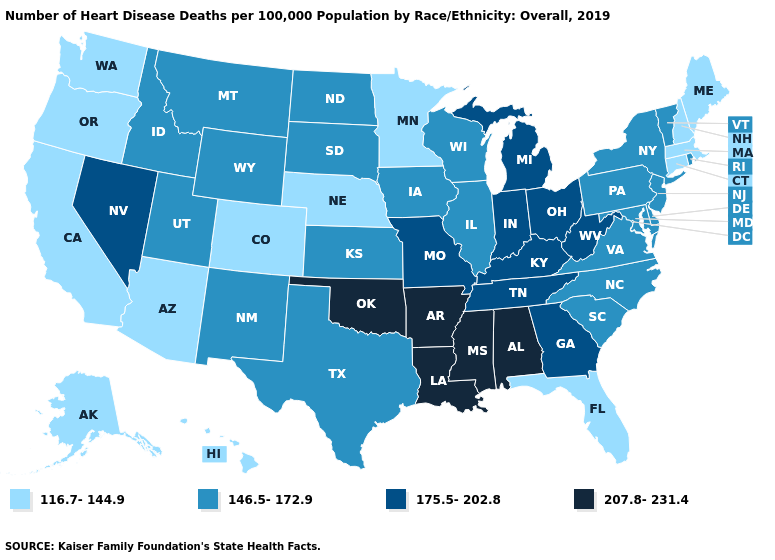What is the value of Maryland?
Short answer required. 146.5-172.9. Among the states that border Kansas , which have the lowest value?
Concise answer only. Colorado, Nebraska. Among the states that border Nebraska , does Kansas have the lowest value?
Keep it brief. No. What is the lowest value in the MidWest?
Concise answer only. 116.7-144.9. What is the value of Connecticut?
Give a very brief answer. 116.7-144.9. What is the value of West Virginia?
Be succinct. 175.5-202.8. What is the value of South Carolina?
Keep it brief. 146.5-172.9. Which states hav the highest value in the South?
Quick response, please. Alabama, Arkansas, Louisiana, Mississippi, Oklahoma. What is the value of Missouri?
Write a very short answer. 175.5-202.8. Name the states that have a value in the range 116.7-144.9?
Be succinct. Alaska, Arizona, California, Colorado, Connecticut, Florida, Hawaii, Maine, Massachusetts, Minnesota, Nebraska, New Hampshire, Oregon, Washington. What is the value of Indiana?
Give a very brief answer. 175.5-202.8. What is the lowest value in states that border Massachusetts?
Short answer required. 116.7-144.9. What is the value of Maine?
Write a very short answer. 116.7-144.9. How many symbols are there in the legend?
Quick response, please. 4. Name the states that have a value in the range 116.7-144.9?
Answer briefly. Alaska, Arizona, California, Colorado, Connecticut, Florida, Hawaii, Maine, Massachusetts, Minnesota, Nebraska, New Hampshire, Oregon, Washington. 